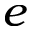<formula> <loc_0><loc_0><loc_500><loc_500>e</formula> 